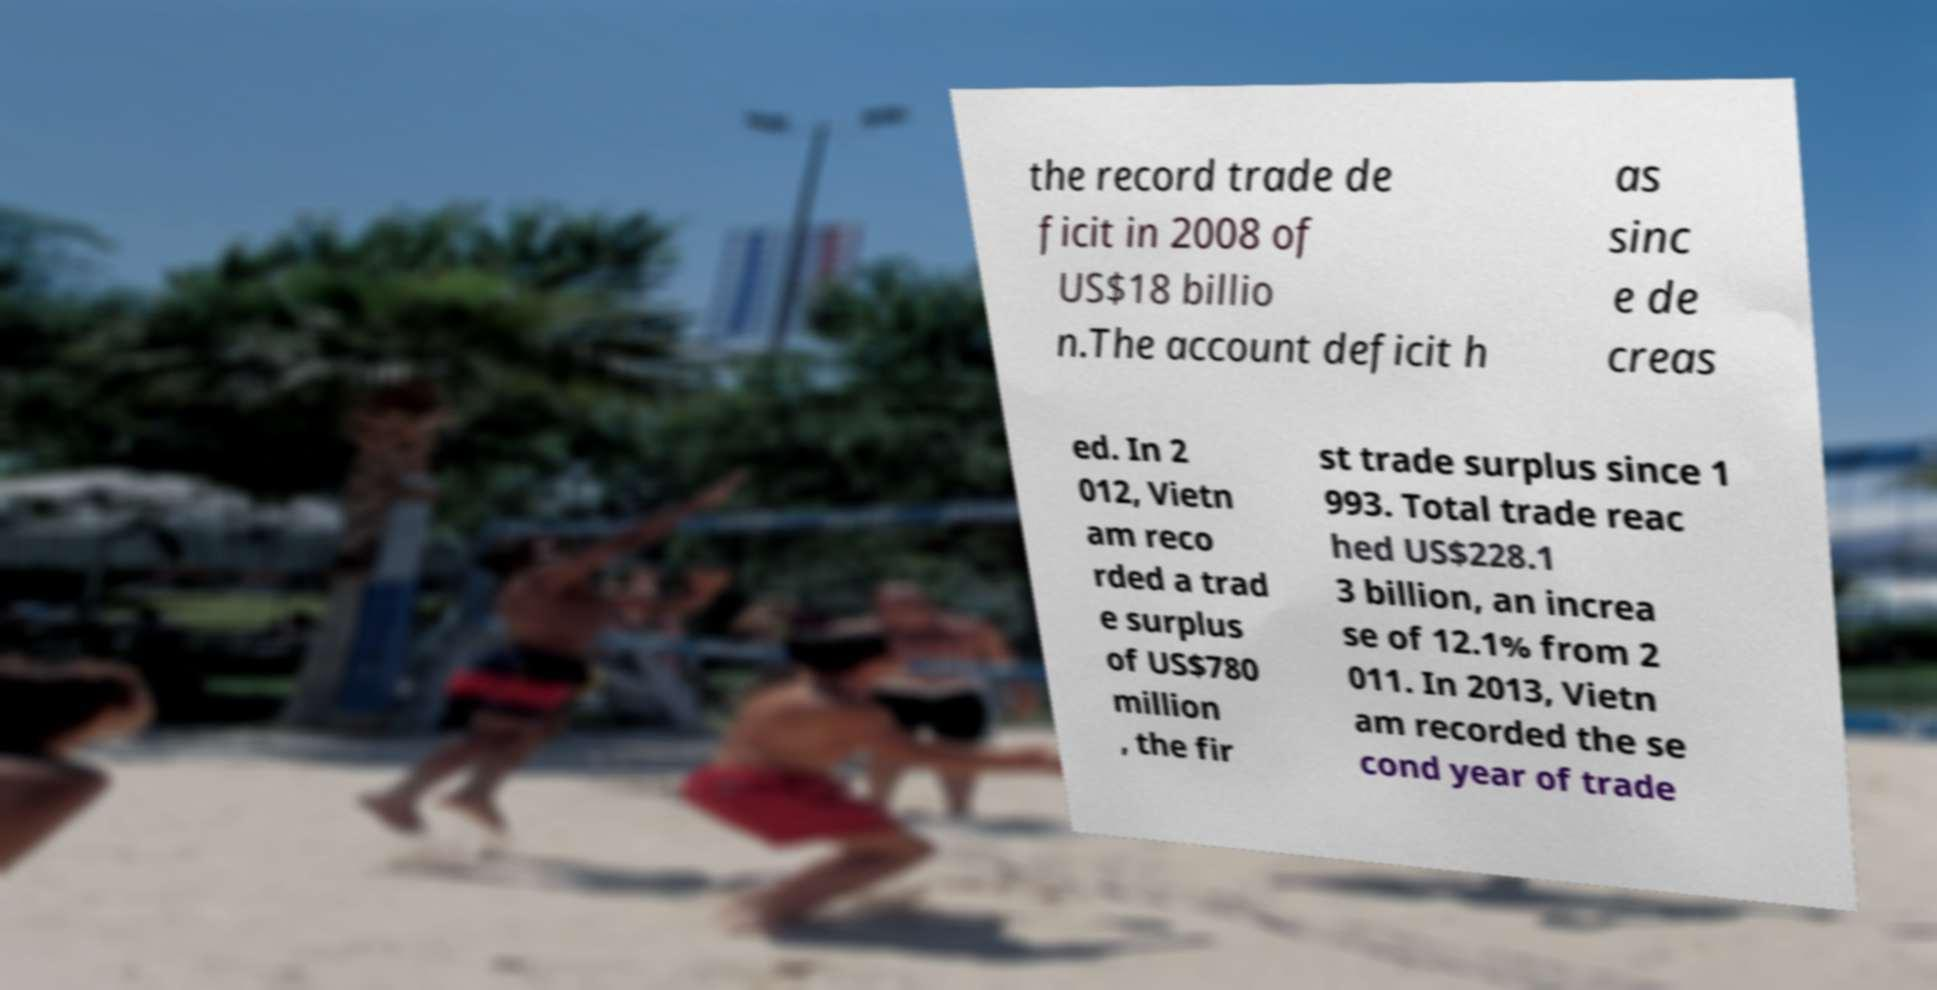There's text embedded in this image that I need extracted. Can you transcribe it verbatim? the record trade de ficit in 2008 of US$18 billio n.The account deficit h as sinc e de creas ed. In 2 012, Vietn am reco rded a trad e surplus of US$780 million , the fir st trade surplus since 1 993. Total trade reac hed US$228.1 3 billion, an increa se of 12.1% from 2 011. In 2013, Vietn am recorded the se cond year of trade 